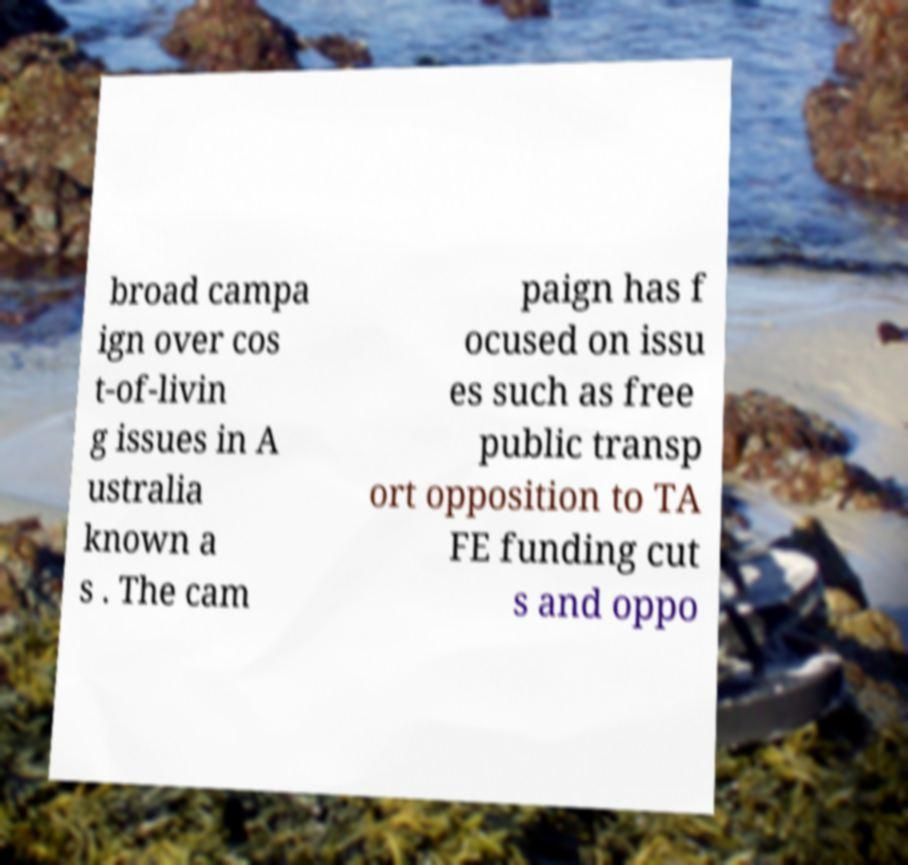I need the written content from this picture converted into text. Can you do that? broad campa ign over cos t-of-livin g issues in A ustralia known a s . The cam paign has f ocused on issu es such as free public transp ort opposition to TA FE funding cut s and oppo 